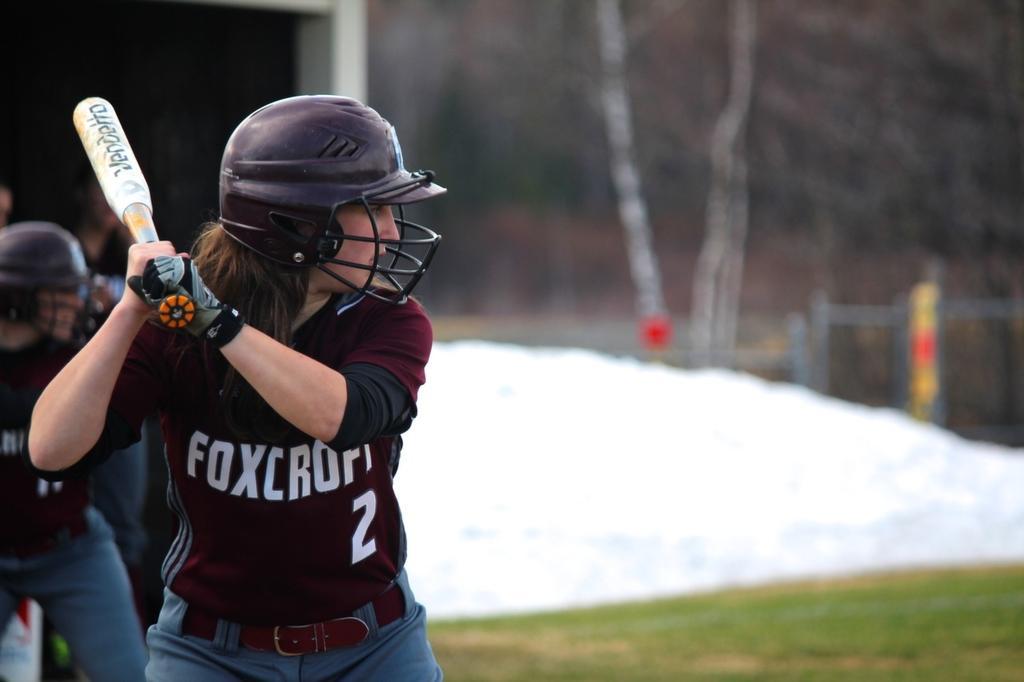How would you summarize this image in a sentence or two? On the left side, there are two persons in the brown color T-shirts, one of them is holding a bat, standing. On the right side, there's grass on the ground. 